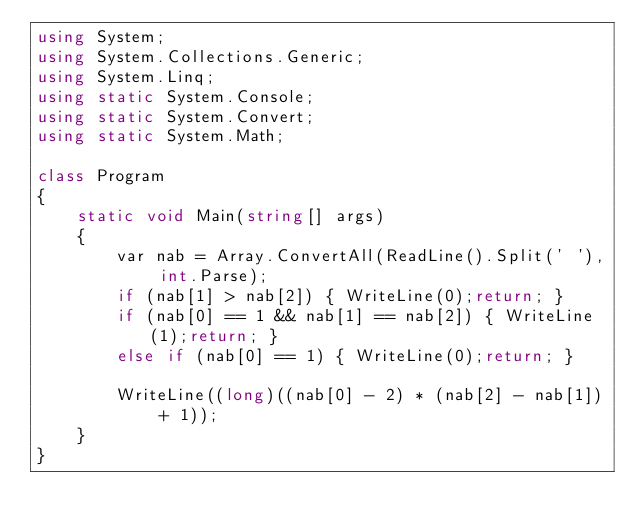Convert code to text. <code><loc_0><loc_0><loc_500><loc_500><_C#_>using System;
using System.Collections.Generic;
using System.Linq;
using static System.Console;
using static System.Convert;
using static System.Math;

class Program
{
    static void Main(string[] args)
    {
        var nab = Array.ConvertAll(ReadLine().Split(' '), int.Parse);
        if (nab[1] > nab[2]) { WriteLine(0);return; }
        if (nab[0] == 1 && nab[1] == nab[2]) { WriteLine(1);return; }
        else if (nab[0] == 1) { WriteLine(0);return; }

        WriteLine((long)((nab[0] - 2) * (nab[2] - nab[1]) + 1));
    }
}
</code> 